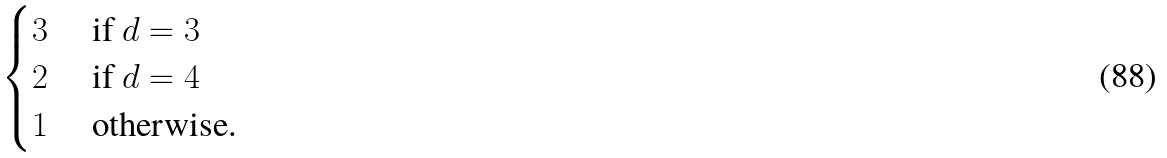Convert formula to latex. <formula><loc_0><loc_0><loc_500><loc_500>\begin{cases} 3 & \text { if } d = 3 \\ 2 & \text { if } d = 4 \\ 1 & \text { otherwise. } \end{cases}</formula> 